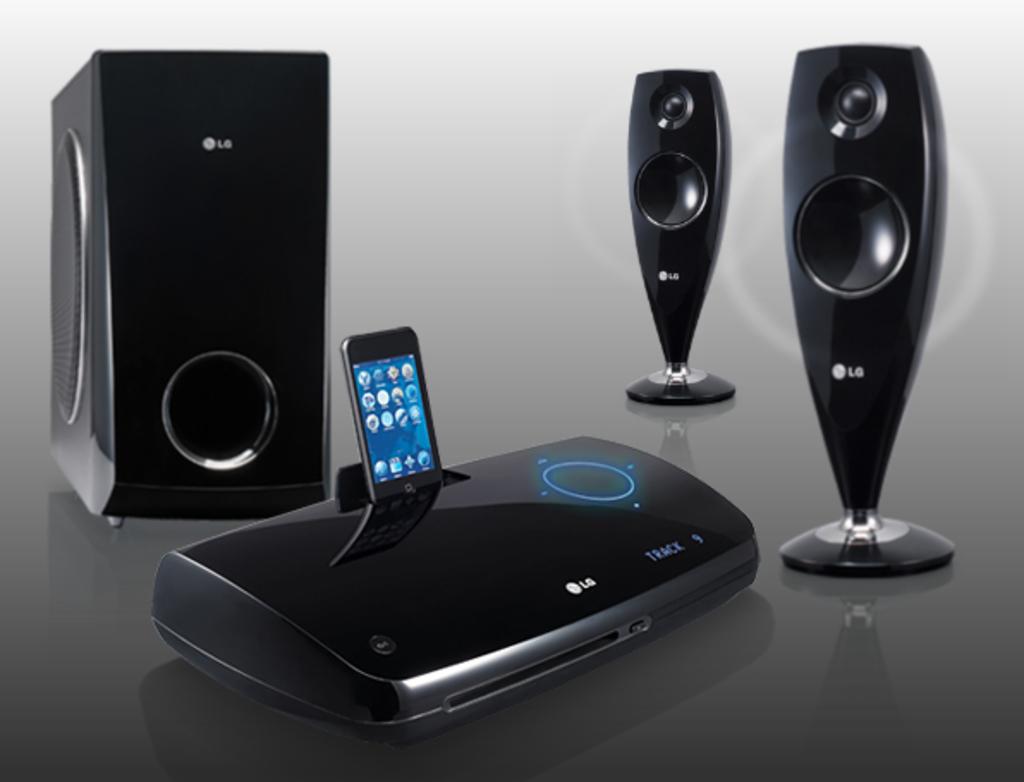What brand is this?
Your answer should be very brief. Lg. 